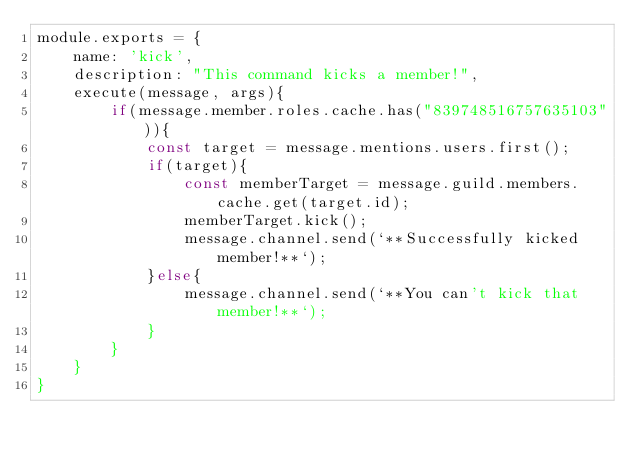Convert code to text. <code><loc_0><loc_0><loc_500><loc_500><_JavaScript_>module.exports = {
    name: 'kick',
    description: "This command kicks a member!",
    execute(message, args){
		if(message.member.roles.cache.has("839748516757635103")){
			const target = message.mentions.users.first();
			if(target){
				const memberTarget = message.guild.members.cache.get(target.id);
				memberTarget.kick();
				message.channel.send(`**Successfully kicked member!**`);
			}else{
				message.channel.send(`**You can't kick that member!**`);
			}
		}
    }
}</code> 